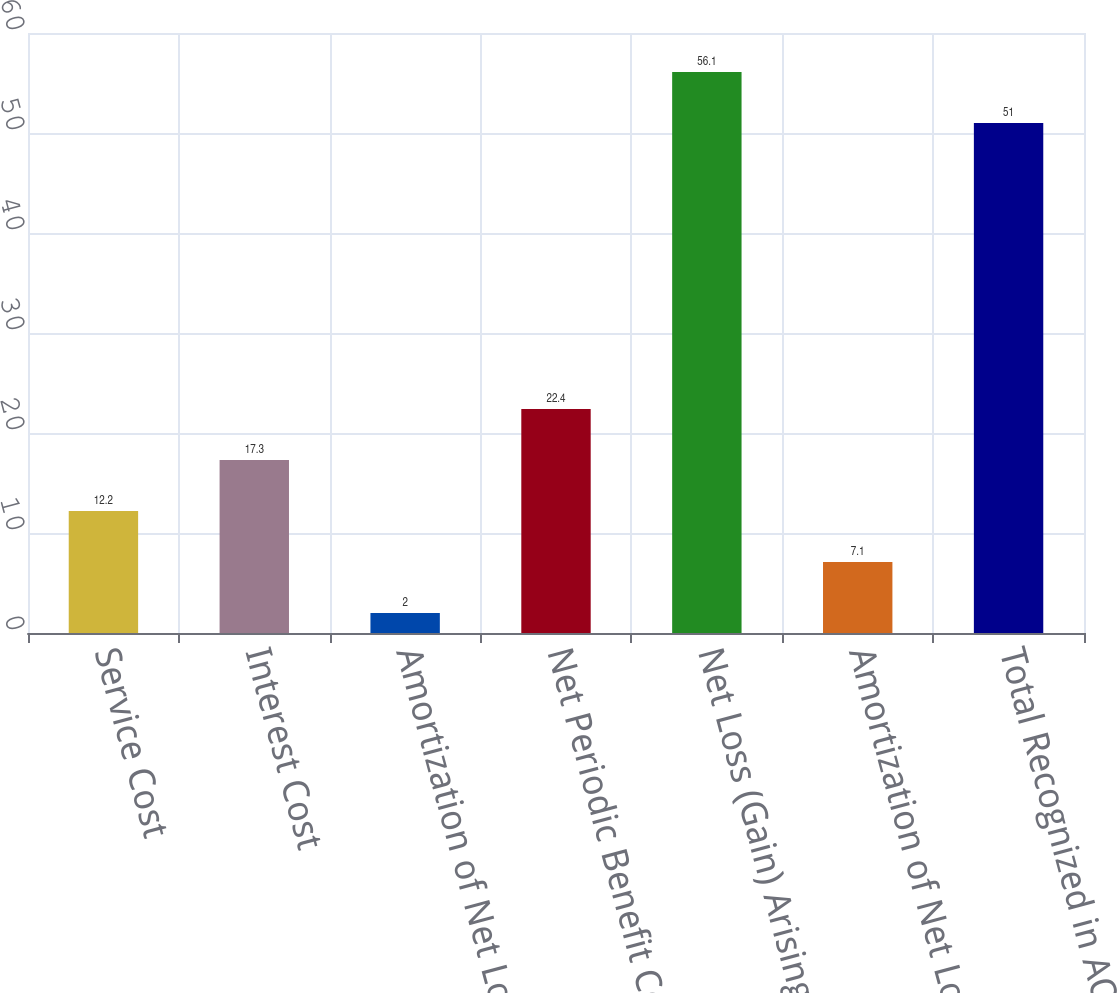Convert chart. <chart><loc_0><loc_0><loc_500><loc_500><bar_chart><fcel>Service Cost<fcel>Interest Cost<fcel>Amortization of Net Loss and<fcel>Net Periodic Benefit Cost<fcel>Net Loss (Gain) Arising During<fcel>Amortization of Net Loss<fcel>Total Recognized in AOCL<nl><fcel>12.2<fcel>17.3<fcel>2<fcel>22.4<fcel>56.1<fcel>7.1<fcel>51<nl></chart> 